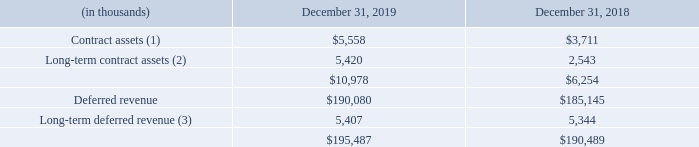Contract assets and deferred revenue
(1) Included in other current assets. (2) Included in other long-term assets. (3) Included in other long-term liabilities.
Contract assets are client committed amounts for which revenue recognized exceeds the amount billed to the client and the right to payment is subject to conditions other than the passage of time, such as the completion of a related performance obligation. Deferred revenue consists of billings and payments received in advance of revenue recognition. Contract assets and deferred revenue are netted at the contract level for each reporting period.
The change in deferred revenue in the year ended December 31, 2019 was primarily due to new billings in advance of revenue recognition, partially offset by revenue recognized during the period that was included in deferred revenue at December 31, 2018.
What is the change in deferred revenue in the year ended December 31, 2019 primarily due to? New billings in advance of revenue recognition, partially offset by revenue recognized during the period that was included in deferred revenue at december 31, 2018. What are contract assets and long-term contract assets respectively classified under? Other current assets, other long-term assets. What are long-term deferred revenue respectively classified under? Other long-term liabilities. What is the percentage change in contract assets between 2018 and 2019?
Answer scale should be: percent. (5,558 - 3,711)/3,711 
Answer: 49.77. What is the percentage change in long-term contract assets between 2018 and 2019?
Answer scale should be: percent. (5,420 - 2,543)/2,543 
Answer: 113.13. What is the percentage change in long-term deferred revenue between 2018 and 2019?
Answer scale should be: percent. (5,407 - 5,344)/5,344 
Answer: 1.18. 